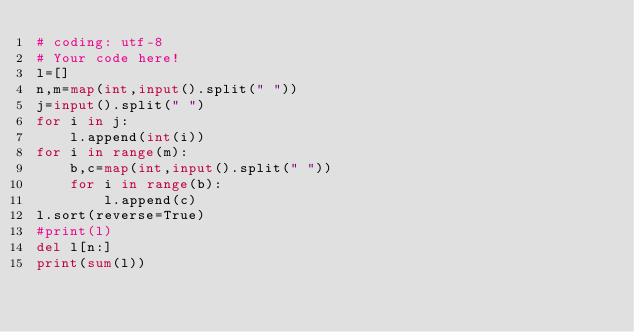Convert code to text. <code><loc_0><loc_0><loc_500><loc_500><_Python_># coding: utf-8
# Your code here!
l=[]
n,m=map(int,input().split(" "))
j=input().split(" ")
for i in j:
    l.append(int(i))
for i in range(m):
    b,c=map(int,input().split(" "))
    for i in range(b):
        l.append(c)
l.sort(reverse=True)
#print(l)
del l[n:]
print(sum(l))
</code> 